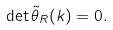Convert formula to latex. <formula><loc_0><loc_0><loc_500><loc_500>\det \tilde { \theta } _ { R } ( k ) = 0 .</formula> 